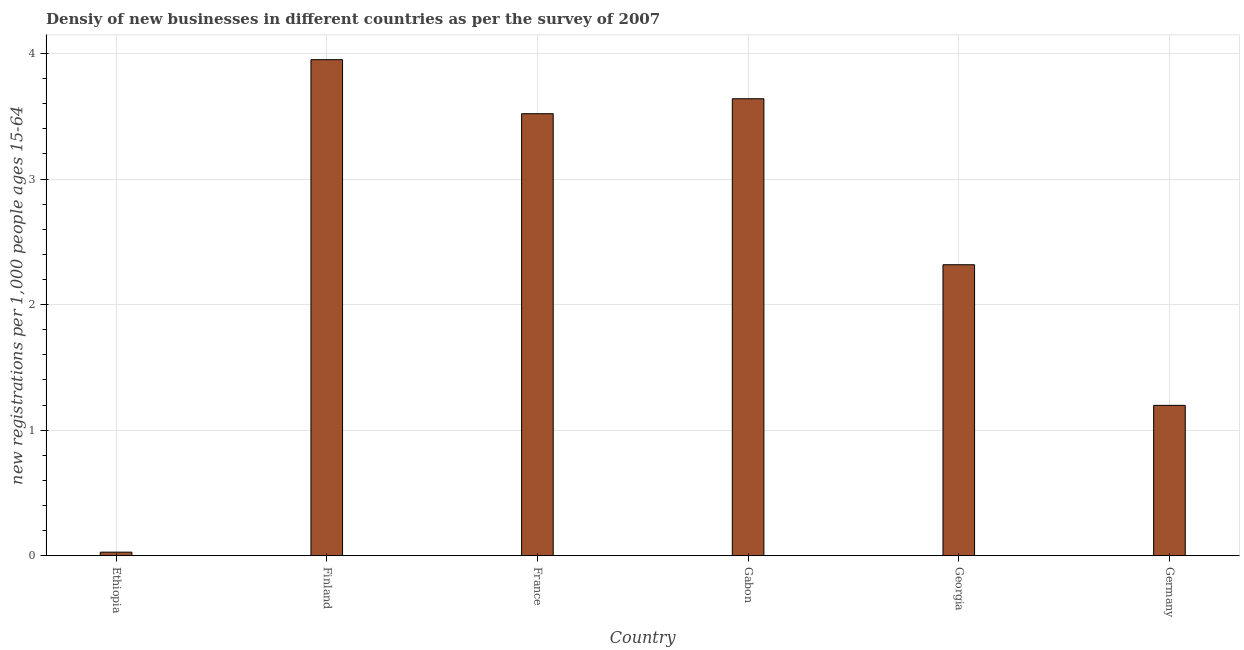Does the graph contain grids?
Ensure brevity in your answer.  Yes. What is the title of the graph?
Make the answer very short. Densiy of new businesses in different countries as per the survey of 2007. What is the label or title of the Y-axis?
Offer a very short reply. New registrations per 1,0 people ages 15-64. What is the density of new business in France?
Give a very brief answer. 3.52. Across all countries, what is the maximum density of new business?
Make the answer very short. 3.95. Across all countries, what is the minimum density of new business?
Make the answer very short. 0.03. In which country was the density of new business minimum?
Provide a short and direct response. Ethiopia. What is the sum of the density of new business?
Offer a very short reply. 14.66. What is the difference between the density of new business in Finland and Germany?
Make the answer very short. 2.75. What is the average density of new business per country?
Your response must be concise. 2.44. What is the median density of new business?
Your answer should be compact. 2.92. In how many countries, is the density of new business greater than 0.4 ?
Your answer should be very brief. 5. What is the ratio of the density of new business in Ethiopia to that in Georgia?
Keep it short and to the point. 0.01. Is the density of new business in Ethiopia less than that in France?
Provide a succinct answer. Yes. What is the difference between the highest and the second highest density of new business?
Keep it short and to the point. 0.31. Is the sum of the density of new business in France and Germany greater than the maximum density of new business across all countries?
Ensure brevity in your answer.  Yes. What is the difference between the highest and the lowest density of new business?
Ensure brevity in your answer.  3.92. In how many countries, is the density of new business greater than the average density of new business taken over all countries?
Give a very brief answer. 3. How many bars are there?
Offer a very short reply. 6. How many countries are there in the graph?
Provide a short and direct response. 6. What is the difference between two consecutive major ticks on the Y-axis?
Your response must be concise. 1. What is the new registrations per 1,000 people ages 15-64 of Ethiopia?
Make the answer very short. 0.03. What is the new registrations per 1,000 people ages 15-64 of Finland?
Give a very brief answer. 3.95. What is the new registrations per 1,000 people ages 15-64 in France?
Provide a short and direct response. 3.52. What is the new registrations per 1,000 people ages 15-64 of Gabon?
Offer a terse response. 3.64. What is the new registrations per 1,000 people ages 15-64 of Georgia?
Offer a terse response. 2.32. What is the new registrations per 1,000 people ages 15-64 in Germany?
Give a very brief answer. 1.2. What is the difference between the new registrations per 1,000 people ages 15-64 in Ethiopia and Finland?
Make the answer very short. -3.92. What is the difference between the new registrations per 1,000 people ages 15-64 in Ethiopia and France?
Offer a very short reply. -3.49. What is the difference between the new registrations per 1,000 people ages 15-64 in Ethiopia and Gabon?
Ensure brevity in your answer.  -3.61. What is the difference between the new registrations per 1,000 people ages 15-64 in Ethiopia and Georgia?
Provide a short and direct response. -2.29. What is the difference between the new registrations per 1,000 people ages 15-64 in Ethiopia and Germany?
Your answer should be compact. -1.17. What is the difference between the new registrations per 1,000 people ages 15-64 in Finland and France?
Offer a very short reply. 0.43. What is the difference between the new registrations per 1,000 people ages 15-64 in Finland and Gabon?
Provide a succinct answer. 0.31. What is the difference between the new registrations per 1,000 people ages 15-64 in Finland and Georgia?
Provide a short and direct response. 1.63. What is the difference between the new registrations per 1,000 people ages 15-64 in Finland and Germany?
Your answer should be very brief. 2.75. What is the difference between the new registrations per 1,000 people ages 15-64 in France and Gabon?
Offer a terse response. -0.12. What is the difference between the new registrations per 1,000 people ages 15-64 in France and Georgia?
Keep it short and to the point. 1.2. What is the difference between the new registrations per 1,000 people ages 15-64 in France and Germany?
Keep it short and to the point. 2.32. What is the difference between the new registrations per 1,000 people ages 15-64 in Gabon and Georgia?
Make the answer very short. 1.32. What is the difference between the new registrations per 1,000 people ages 15-64 in Gabon and Germany?
Your response must be concise. 2.44. What is the difference between the new registrations per 1,000 people ages 15-64 in Georgia and Germany?
Your response must be concise. 1.12. What is the ratio of the new registrations per 1,000 people ages 15-64 in Ethiopia to that in Finland?
Offer a terse response. 0.01. What is the ratio of the new registrations per 1,000 people ages 15-64 in Ethiopia to that in France?
Make the answer very short. 0.01. What is the ratio of the new registrations per 1,000 people ages 15-64 in Ethiopia to that in Gabon?
Offer a terse response. 0.01. What is the ratio of the new registrations per 1,000 people ages 15-64 in Ethiopia to that in Georgia?
Your answer should be compact. 0.01. What is the ratio of the new registrations per 1,000 people ages 15-64 in Ethiopia to that in Germany?
Your answer should be compact. 0.02. What is the ratio of the new registrations per 1,000 people ages 15-64 in Finland to that in France?
Ensure brevity in your answer.  1.12. What is the ratio of the new registrations per 1,000 people ages 15-64 in Finland to that in Gabon?
Provide a succinct answer. 1.09. What is the ratio of the new registrations per 1,000 people ages 15-64 in Finland to that in Georgia?
Ensure brevity in your answer.  1.71. What is the ratio of the new registrations per 1,000 people ages 15-64 in Finland to that in Germany?
Provide a succinct answer. 3.3. What is the ratio of the new registrations per 1,000 people ages 15-64 in France to that in Gabon?
Offer a terse response. 0.97. What is the ratio of the new registrations per 1,000 people ages 15-64 in France to that in Georgia?
Ensure brevity in your answer.  1.52. What is the ratio of the new registrations per 1,000 people ages 15-64 in France to that in Germany?
Keep it short and to the point. 2.94. What is the ratio of the new registrations per 1,000 people ages 15-64 in Gabon to that in Georgia?
Make the answer very short. 1.57. What is the ratio of the new registrations per 1,000 people ages 15-64 in Gabon to that in Germany?
Keep it short and to the point. 3.04. What is the ratio of the new registrations per 1,000 people ages 15-64 in Georgia to that in Germany?
Provide a short and direct response. 1.94. 